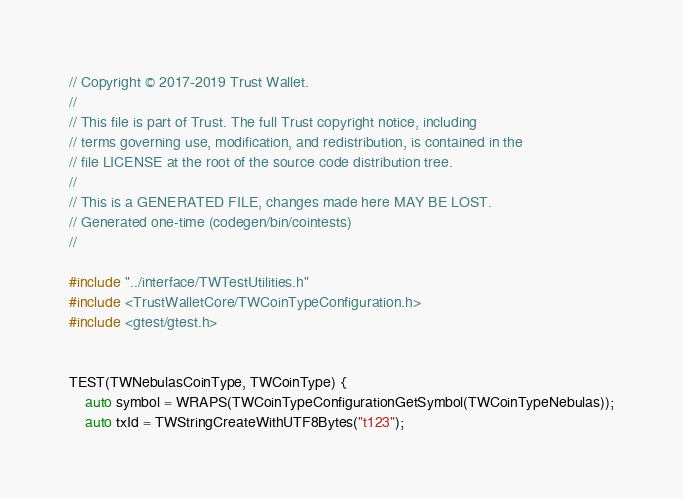Convert code to text. <code><loc_0><loc_0><loc_500><loc_500><_C++_>// Copyright © 2017-2019 Trust Wallet.
//
// This file is part of Trust. The full Trust copyright notice, including
// terms governing use, modification, and redistribution, is contained in the
// file LICENSE at the root of the source code distribution tree.
//
// This is a GENERATED FILE, changes made here MAY BE LOST.
// Generated one-time (codegen/bin/cointests)
//

#include "../interface/TWTestUtilities.h"
#include <TrustWalletCore/TWCoinTypeConfiguration.h>
#include <gtest/gtest.h>


TEST(TWNebulasCoinType, TWCoinType) {
    auto symbol = WRAPS(TWCoinTypeConfigurationGetSymbol(TWCoinTypeNebulas));
    auto txId = TWStringCreateWithUTF8Bytes("t123");</code> 